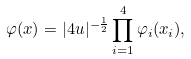<formula> <loc_0><loc_0><loc_500><loc_500>\varphi ( x ) = | 4 u | ^ { - \frac { 1 } { 2 } } \prod _ { i = 1 } ^ { 4 } \varphi _ { i } ( x _ { i } ) ,</formula> 